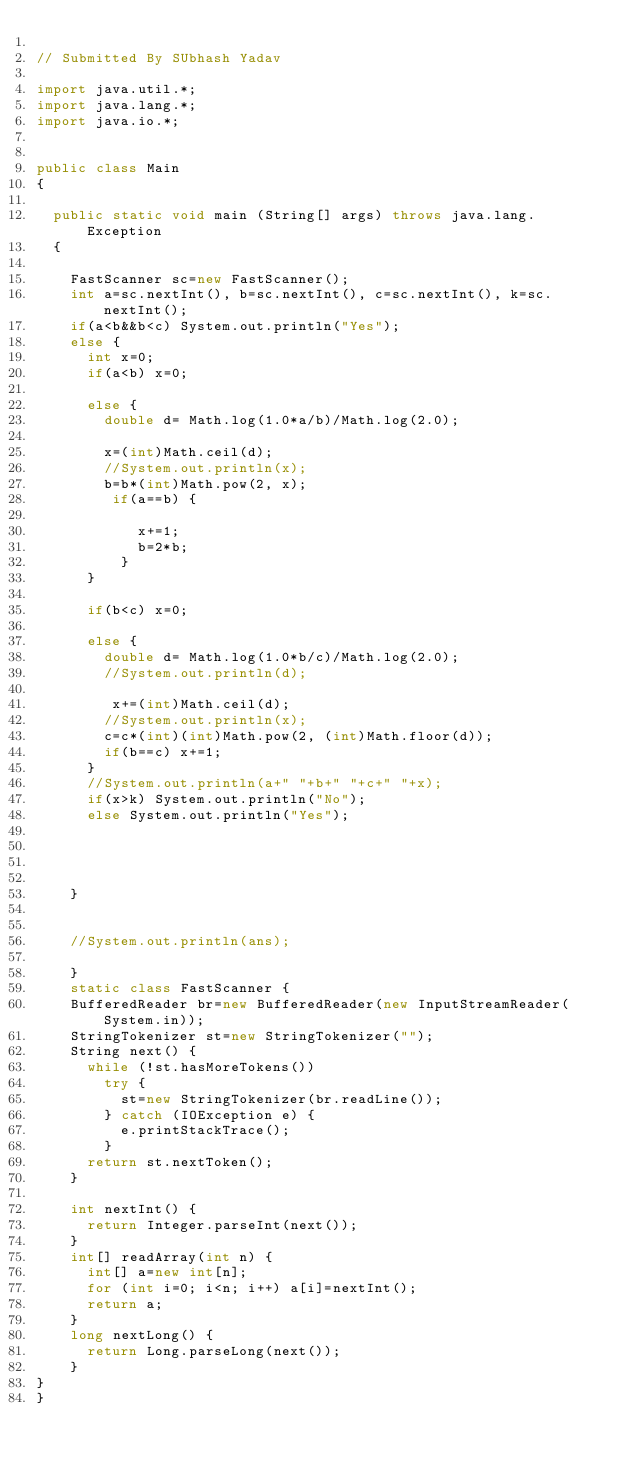<code> <loc_0><loc_0><loc_500><loc_500><_Java_>
// Submitted By SUbhash Yadav

import java.util.*;
import java.lang.*;
import java.io.*;


public class Main
{
	
	public static void main (String[] args) throws java.lang.Exception
	{
		
		FastScanner sc=new FastScanner();
		int a=sc.nextInt(), b=sc.nextInt(), c=sc.nextInt(), k=sc.nextInt();
		if(a<b&&b<c) System.out.println("Yes");
		else {
			int x=0;
			if(a<b) x=0;
		
			else {
				double d= Math.log(1.0*a/b)/Math.log(2.0);
			
				x=(int)Math.ceil(d);
				//System.out.println(x);
				b=b*(int)Math.pow(2, x);
				 if(a==b) {
					 
						x+=1;
						b=2*b;
					}
			}
			
			if(b<c) x=0;
			
			else {
				double d= Math.log(1.0*b/c)/Math.log(2.0);
				//System.out.println(d);
				
				 x+=(int)Math.ceil(d);
				//System.out.println(x);
				c=c*(int)(int)Math.pow(2, (int)Math.floor(d));
				if(b==c) x+=1;
			}
			//System.out.println(a+" "+b+" "+c+" "+x);
			if(x>k) System.out.println("No");
			else System.out.println("Yes");
			
			
			
			
		}
		
		
		//System.out.println(ans);
		
		}
		static class FastScanner {
		BufferedReader br=new BufferedReader(new InputStreamReader(System.in));
		StringTokenizer st=new StringTokenizer("");
		String next() {
			while (!st.hasMoreTokens())
				try {
					st=new StringTokenizer(br.readLine());
				} catch (IOException e) {
					e.printStackTrace();
				}
			return st.nextToken();
		}
		
		int nextInt() {
			return Integer.parseInt(next());
		}
		int[] readArray(int n) {
			int[] a=new int[n];
			for (int i=0; i<n; i++) a[i]=nextInt();
			return a;
		}
		long nextLong() {
			return Long.parseLong(next());
		}
}
}
</code> 